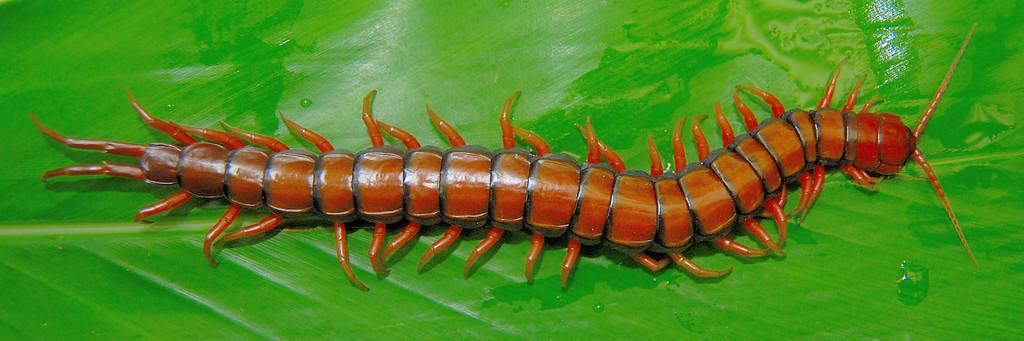What type of creatures are present in the image? There are centipedes in the image. What can be seen on the leaf in the image? There are water droplets on a leaf in the image. What type of knowledge is being shared by the band in the image? There is no band present in the image, so no knowledge can be shared by a band. 